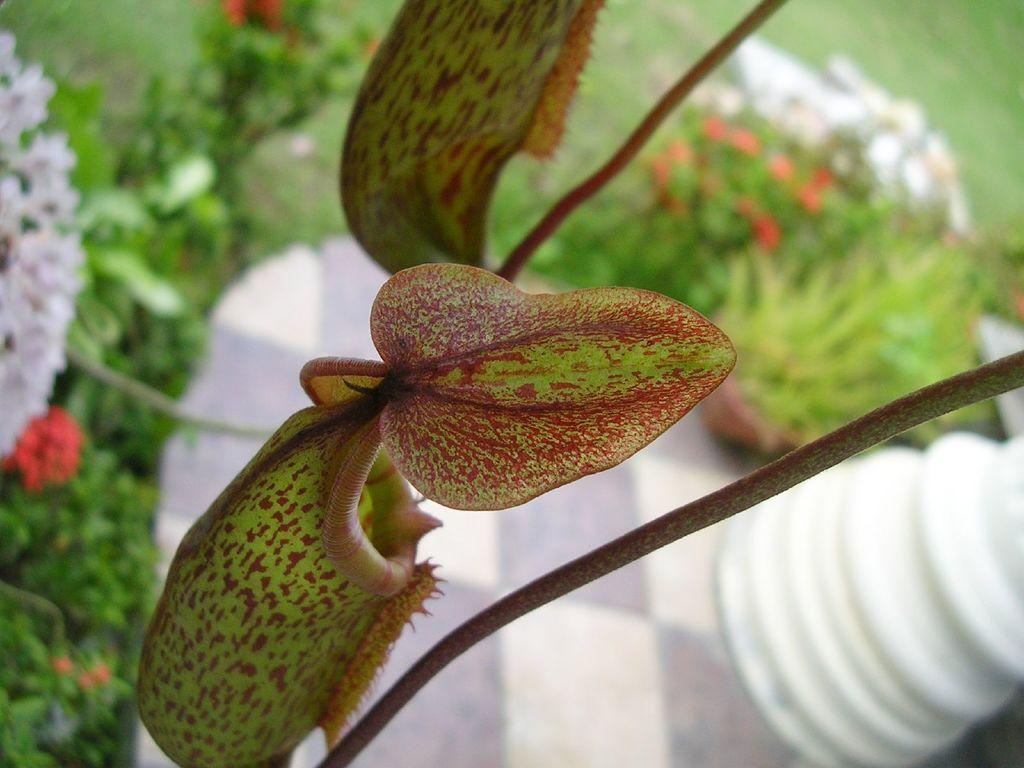What type of vegetation is present in the image? There are leaves on a plant and flowers on other plants in the image. Can you describe the condition of the flowers in the image? The flowers appear blurry in the image. Are there any boys playing with the clover in the image? There is no mention of boys or clover in the image; it only features plants with leaves and flowers. 